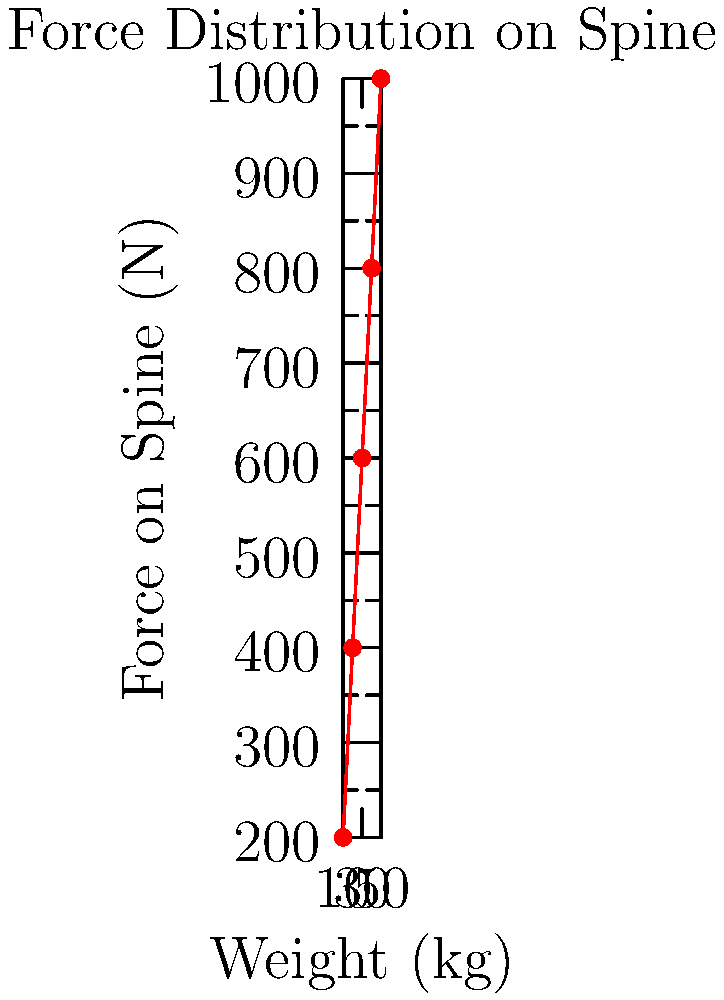Based on the graph showing the relationship between object weight and force exerted on the spine during lifting, what is the approximate increase in spinal force for every 10 kg increase in object weight? Consider the potential health implications of this relationship for individuals engaging in repetitive lifting tasks. To determine the increase in spinal force for every 10 kg increase in object weight, we need to follow these steps:

1. Observe the graph: The x-axis represents weight in kg, and the y-axis represents force on the spine in Newtons (N).

2. Identify the pattern: The relationship appears linear, suggesting a consistent increase in force for each weight increment.

3. Calculate the force increase:
   - At 10 kg, the force is approximately 200 N
   - At 20 kg, the force is approximately 400 N
   - At 30 kg, the force is approximately 600 N
   - At 40 kg, the force is approximately 800 N
   - At 50 kg, the force is approximately 1000 N

4. Determine the force increase for each 10 kg increment:
   $\frac{400 N - 200 N}{20 kg - 10 kg} = \frac{600 N - 400 N}{30 kg - 20 kg} = \frac{800 N - 600 N}{40 kg - 30 kg} = \frac{1000 N - 800 N}{50 kg - 40 kg} = 200 N$

5. Health implications:
   - The consistent increase of 200 N (approximately 20 kg of force) on the spine for every 10 kg increase in object weight demonstrates the significant impact of lifting heavier objects.
   - This linear relationship suggests that the risk of spinal injury increases proportionally with the weight of objects being lifted.
   - For individuals engaging in repetitive lifting tasks, this highlights the importance of proper lifting techniques, strength training, and implementing weight limits to reduce the risk of spinal injuries and chronic back pain.
   - It also emphasizes the need for ergonomic interventions and mechanical assistance when handling heavier loads to minimize the cumulative stress on the spine over time.
Answer: 200 N increase in spinal force per 10 kg increase in object weight 